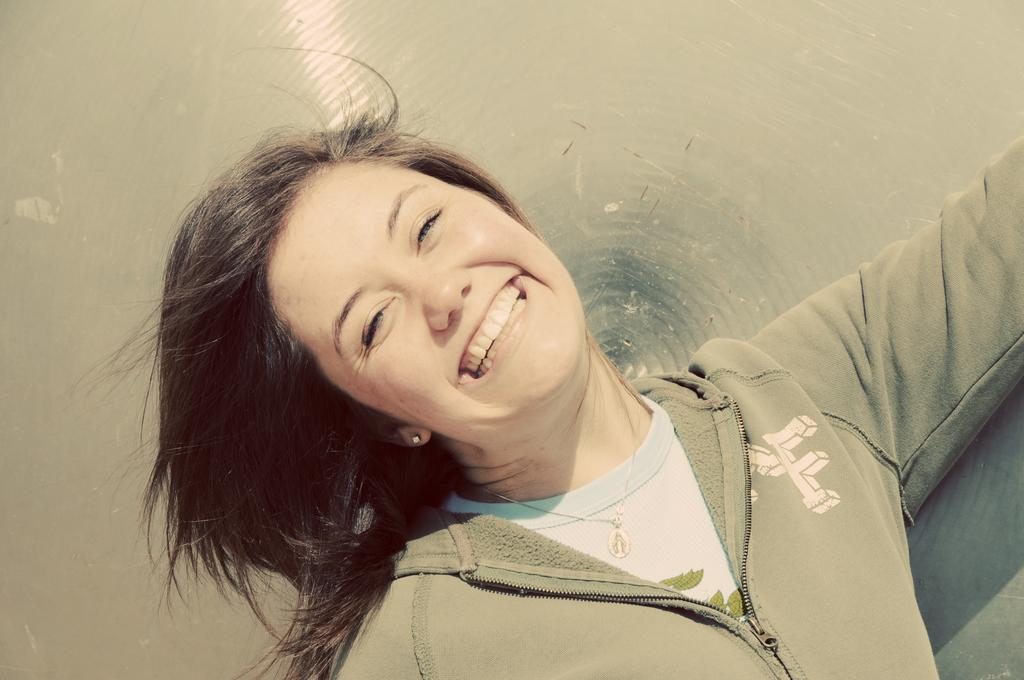Who is the main subject in the image? There is a girl in the image. What is the girl wearing? The girl is wearing a green jacket. Where is the girl positioned in the image? The girl is standing in the front. What is the girl's facial expression in the image? The girl is smiling. What is the girl doing in the image? The girl is giving a pose to the camera. What type of expert advice can be seen in the image? There is no expert advice present in the image; it features a girl giving a pose to the camera. What kind of curve can be observed in the girl's pose in the image? There is no curve mentioned in the provided facts, and the girl's pose is not described in detail. 